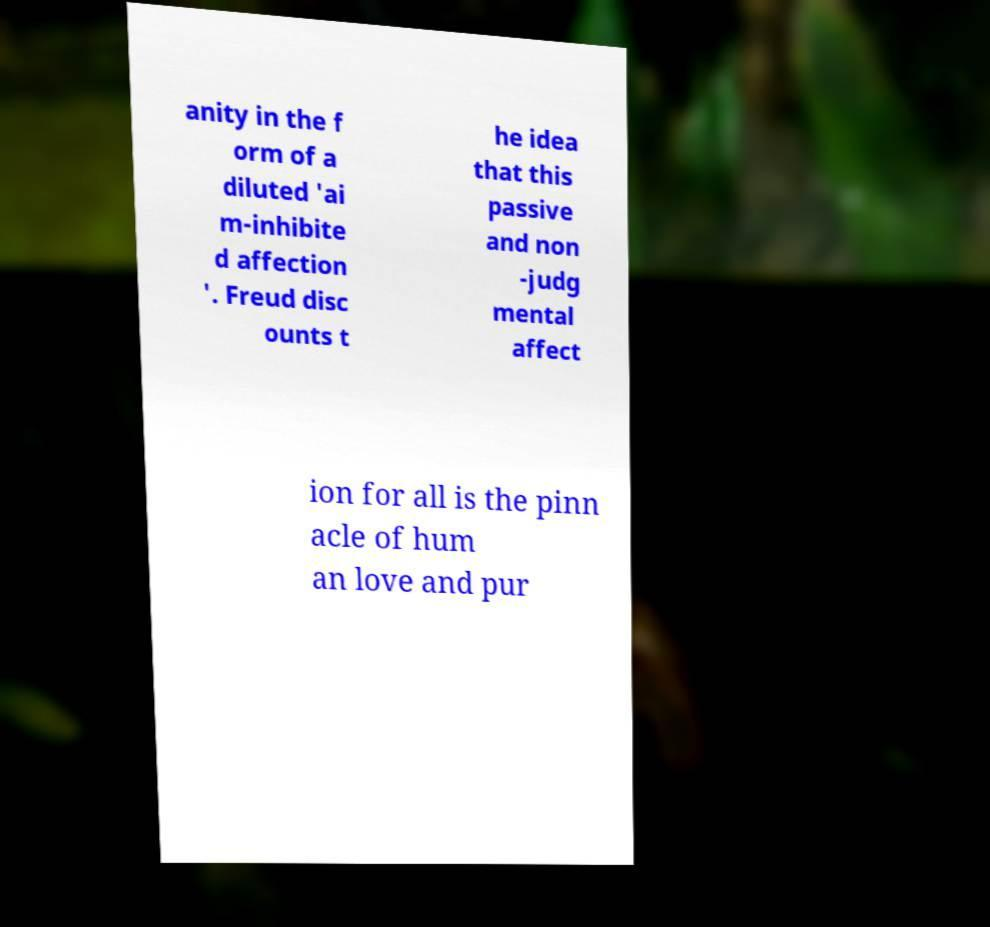Can you read and provide the text displayed in the image?This photo seems to have some interesting text. Can you extract and type it out for me? anity in the f orm of a diluted 'ai m-inhibite d affection '. Freud disc ounts t he idea that this passive and non -judg mental affect ion for all is the pinn acle of hum an love and pur 